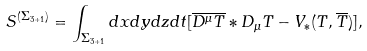<formula> <loc_0><loc_0><loc_500><loc_500>S ^ { ( \Sigma _ { 3 + 1 } ) } = \int _ { \Sigma _ { 3 + 1 } } d x d y d z d t [ \overline { D ^ { \mu } T } * D _ { \mu } T - V _ { * } ( T , \overline { T } ) ] ,</formula> 